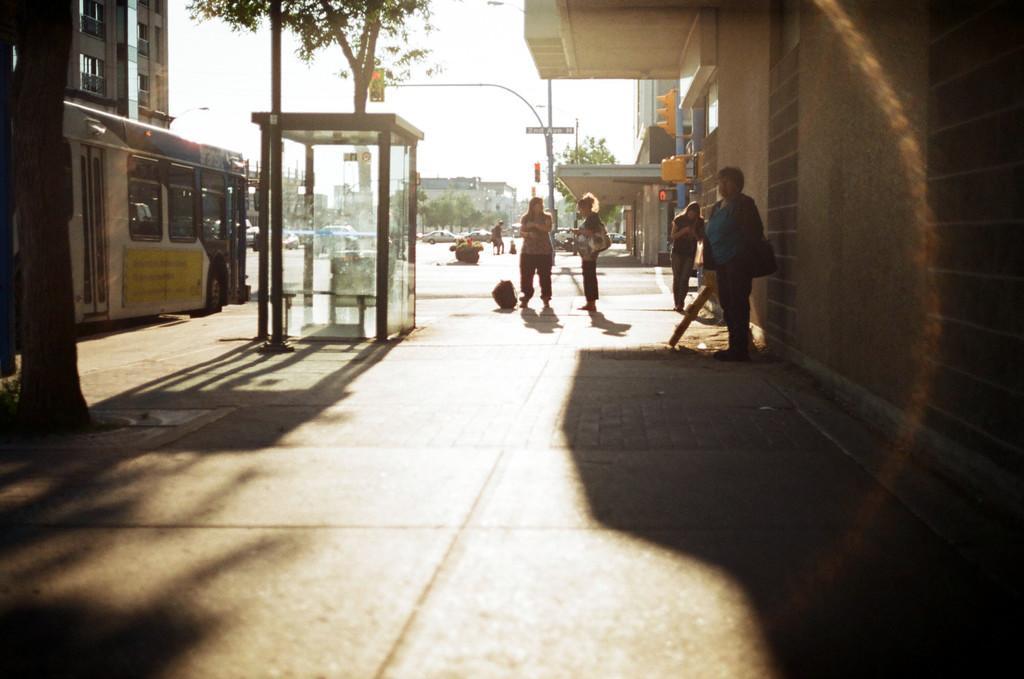How would you summarize this image in a sentence or two? In this picture I can see some vehicles are on the roads, side we can see some trees, glass rooms, few people are in front of the buildings. 